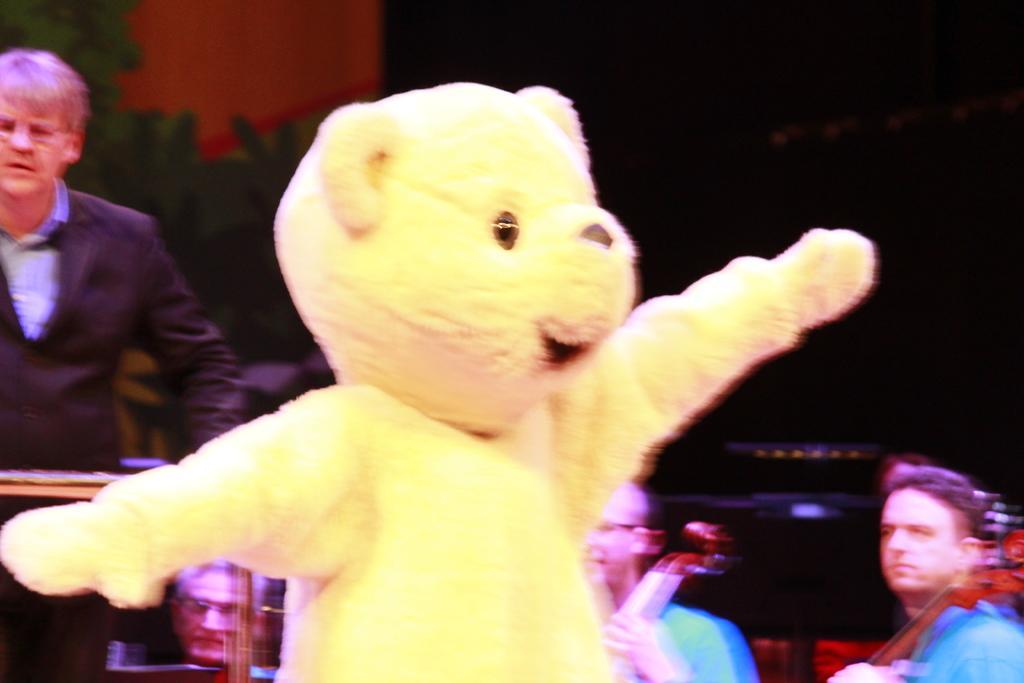Describe this image in one or two sentences. In the center of the image we can see a doll. To the left side of the image we can see a person wearing a coat is standing. In the background, we can see two persons are holding a violin in their hands. 